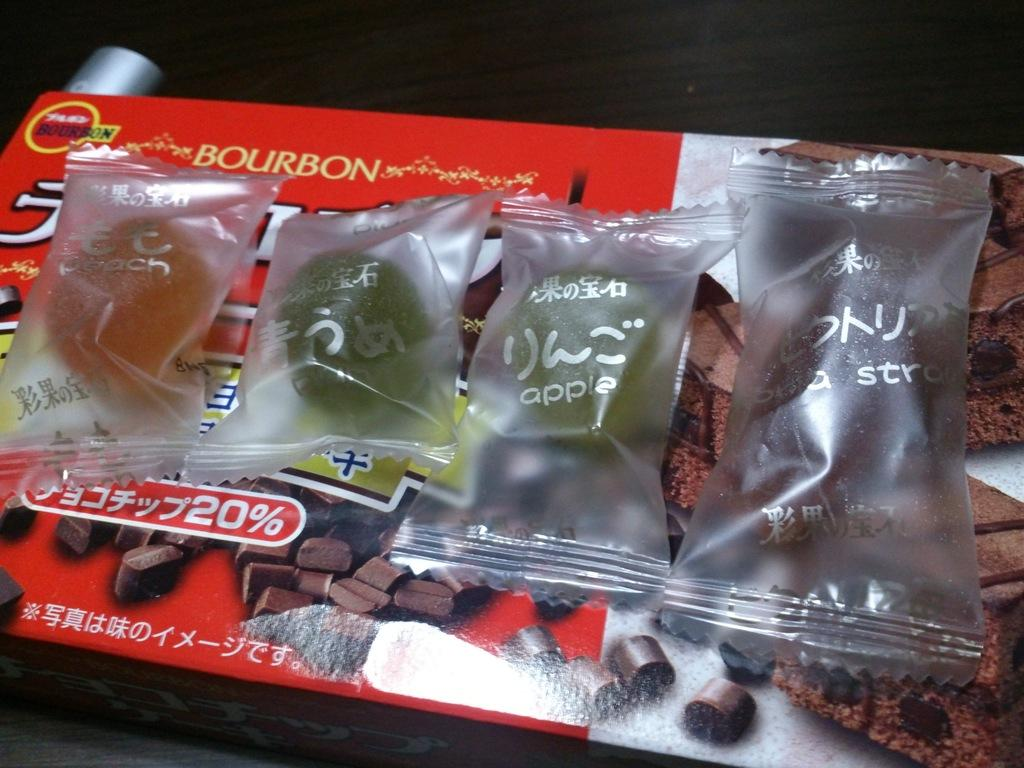What is on the box in the image? There are candy wrappers and chocolate cookies on the box. What can be inferred about the color of the background in the image? The background of the image is dark. What type of band is playing near the ocean in the image? There is no band or ocean present in the image; it only features a box with candy wrappers and chocolate cookies. 